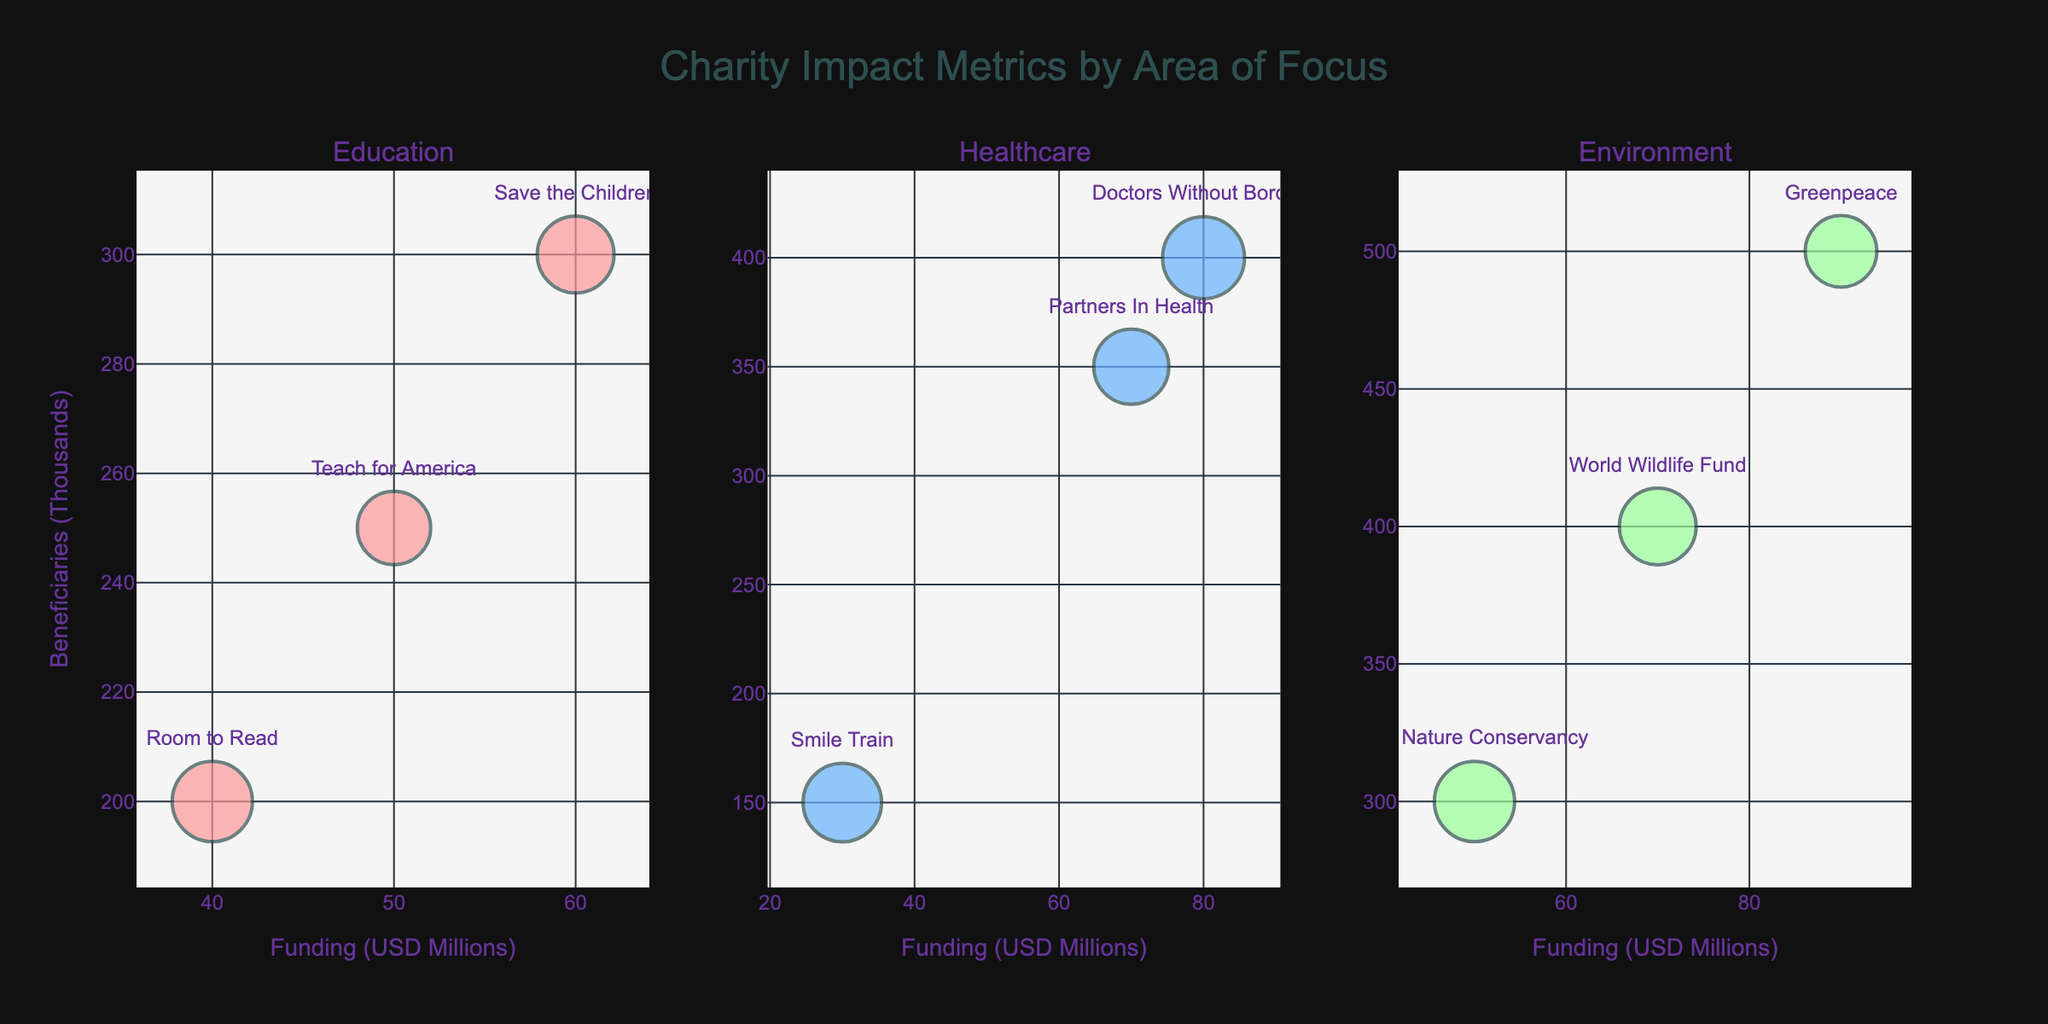How many areas of focus are represented in the figure? The title of the figure "Charity Impact Metrics by Area of Focus" suggests it has multiple areas. By looking at the three subplot titles, we see Education, Healthcare, and Environment as distinct areas of focus.
Answer: 3 Which organization in the 'Education' area has the highest transparency rating? By observing the bubbles in the Education subplot, the text labels denote organizations. Room to Read has a transparency rating of 4.7, which is the highest among the bubbles in the Education section.
Answer: Room to Read How much total funding is received by organizations within the 'Healthcare' area? Each bubble's x-axis position represents the funding for Healthcare organizations: Doctors Without Borders (80), Smile Train (30), Partners In Health (70). Summing these values: 80 + 30 + 70 = 180 million USD.
Answer: 180 million USD What is the average number of beneficiaries across all 'Environment' area organizations? The y-axis shows the number of beneficiaries for the Environment bubbles: Greenpeace (500), World Wildlife Fund (400), The Nature Conservancy (300). Summing these and dividing by the number of organizations: (500 + 400 + 300) / 3 = 400 thousand.
Answer: 400 thousand Which area has the organization with the largest bubble size? Bubble size represents transparency rating, magnified by a scale. The largest bubble in each subplot is checked, with Healthcare's Doctors Without Borders having a transparency rating of 4.8, which represents the largest bubble size.
Answer: Healthcare Which 'Environment' organization reaches the fewest beneficiaries? In the Environment subplot, examining the y-axis positions (beneficiaries), The Nature Conservancy reaches 300 thousand beneficiaries, which is the smallest in this area.
Answer: The Nature Conservancy Which organization in the `Healthcare` area has secured the least funding and what’s its impact metric? In the Healthcare subplot, the lowest x-axis value represents funding. Smile Train has the least funding of 30 million USD. According to its hover info, Smile Train's impact metric is 'Cleft Surgeries'.
Answer: Smile Train, Cleft Surgeries How does the transparency rating of GreenPeace compare to that of Partners In Health? GreenPeace and Partners In Health belong to different subplots but their bubble sizes and hover info reveal their transparency ratings: GreenPeace (4.2) is lower than Partners In Health (4.4).
Answer: GreenPeace's rating is lower Which `Education` organization has the least impact in terms of beneficiaries? For Education subplot, the y-axis indicates beneficiaries. Room to Read reaches 200 thousand beneficiaries, the least among the Education organizations.
Answer: Room to Read 